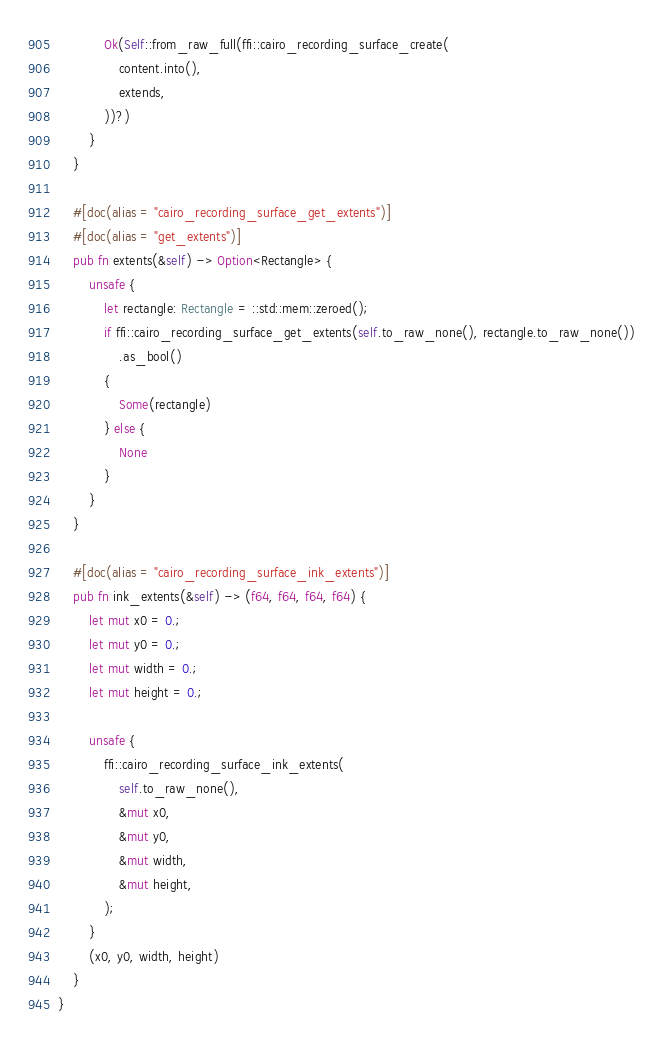<code> <loc_0><loc_0><loc_500><loc_500><_Rust_>            Ok(Self::from_raw_full(ffi::cairo_recording_surface_create(
                content.into(),
                extends,
            ))?)
        }
    }

    #[doc(alias = "cairo_recording_surface_get_extents")]
    #[doc(alias = "get_extents")]
    pub fn extents(&self) -> Option<Rectangle> {
        unsafe {
            let rectangle: Rectangle = ::std::mem::zeroed();
            if ffi::cairo_recording_surface_get_extents(self.to_raw_none(), rectangle.to_raw_none())
                .as_bool()
            {
                Some(rectangle)
            } else {
                None
            }
        }
    }

    #[doc(alias = "cairo_recording_surface_ink_extents")]
    pub fn ink_extents(&self) -> (f64, f64, f64, f64) {
        let mut x0 = 0.;
        let mut y0 = 0.;
        let mut width = 0.;
        let mut height = 0.;

        unsafe {
            ffi::cairo_recording_surface_ink_extents(
                self.to_raw_none(),
                &mut x0,
                &mut y0,
                &mut width,
                &mut height,
            );
        }
        (x0, y0, width, height)
    }
}
</code> 